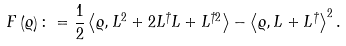<formula> <loc_0><loc_0><loc_500><loc_500>F \left ( \varrho \right ) \colon = \frac { 1 } { 2 } \left \langle \varrho , L ^ { 2 } + 2 L ^ { \dagger } L + L ^ { \dagger 2 } \right \rangle - \left \langle \varrho , L + L ^ { \dagger } \right \rangle ^ { 2 } .</formula> 